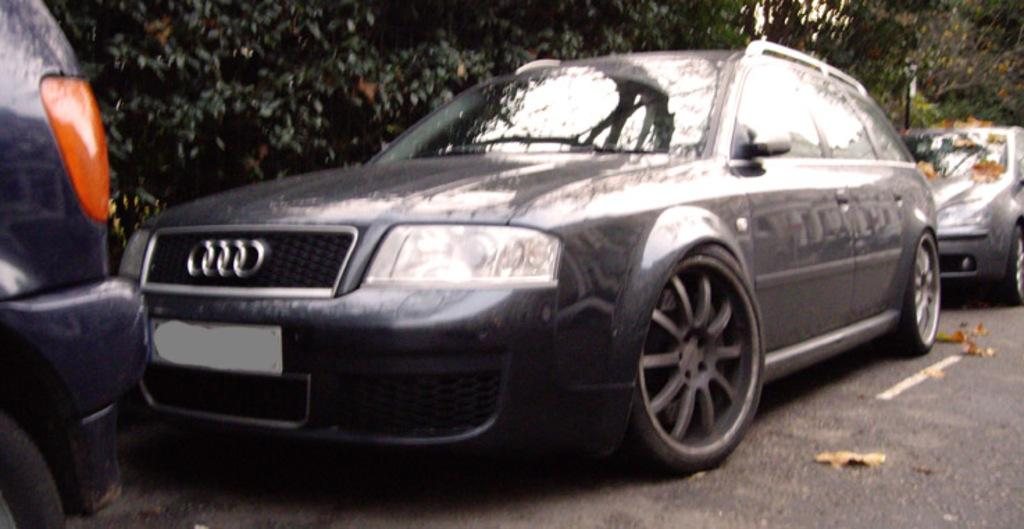What can be seen on the road in the image? There are vehicles parked on the road in the image. What is visible in the distance behind the parked vehicles? There are trees visible in the background of the image. What type of writing can be seen on the ocean in the image? There is no ocean or writing present in the image; it features parked vehicles on a road with trees in the background. 